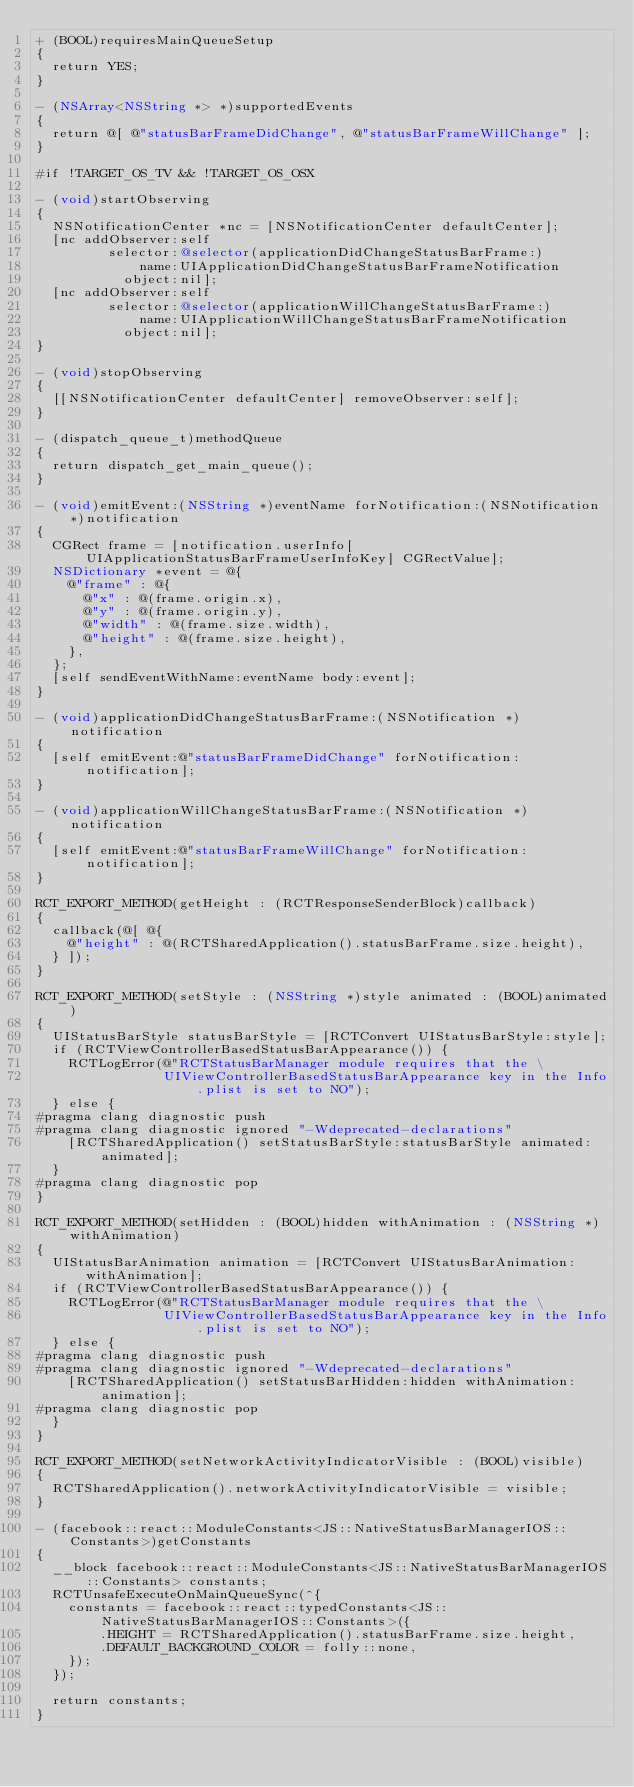<code> <loc_0><loc_0><loc_500><loc_500><_ObjectiveC_>+ (BOOL)requiresMainQueueSetup
{
  return YES;
}

- (NSArray<NSString *> *)supportedEvents
{
  return @[ @"statusBarFrameDidChange", @"statusBarFrameWillChange" ];
}

#if !TARGET_OS_TV && !TARGET_OS_OSX

- (void)startObserving
{
  NSNotificationCenter *nc = [NSNotificationCenter defaultCenter];
  [nc addObserver:self
         selector:@selector(applicationDidChangeStatusBarFrame:)
             name:UIApplicationDidChangeStatusBarFrameNotification
           object:nil];
  [nc addObserver:self
         selector:@selector(applicationWillChangeStatusBarFrame:)
             name:UIApplicationWillChangeStatusBarFrameNotification
           object:nil];
}

- (void)stopObserving
{
  [[NSNotificationCenter defaultCenter] removeObserver:self];
}

- (dispatch_queue_t)methodQueue
{
  return dispatch_get_main_queue();
}

- (void)emitEvent:(NSString *)eventName forNotification:(NSNotification *)notification
{
  CGRect frame = [notification.userInfo[UIApplicationStatusBarFrameUserInfoKey] CGRectValue];
  NSDictionary *event = @{
    @"frame" : @{
      @"x" : @(frame.origin.x),
      @"y" : @(frame.origin.y),
      @"width" : @(frame.size.width),
      @"height" : @(frame.size.height),
    },
  };
  [self sendEventWithName:eventName body:event];
}

- (void)applicationDidChangeStatusBarFrame:(NSNotification *)notification
{
  [self emitEvent:@"statusBarFrameDidChange" forNotification:notification];
}

- (void)applicationWillChangeStatusBarFrame:(NSNotification *)notification
{
  [self emitEvent:@"statusBarFrameWillChange" forNotification:notification];
}

RCT_EXPORT_METHOD(getHeight : (RCTResponseSenderBlock)callback)
{
  callback(@[ @{
    @"height" : @(RCTSharedApplication().statusBarFrame.size.height),
  } ]);
}

RCT_EXPORT_METHOD(setStyle : (NSString *)style animated : (BOOL)animated)
{
  UIStatusBarStyle statusBarStyle = [RCTConvert UIStatusBarStyle:style];
  if (RCTViewControllerBasedStatusBarAppearance()) {
    RCTLogError(@"RCTStatusBarManager module requires that the \
                UIViewControllerBasedStatusBarAppearance key in the Info.plist is set to NO");
  } else {
#pragma clang diagnostic push
#pragma clang diagnostic ignored "-Wdeprecated-declarations"
    [RCTSharedApplication() setStatusBarStyle:statusBarStyle animated:animated];
  }
#pragma clang diagnostic pop
}

RCT_EXPORT_METHOD(setHidden : (BOOL)hidden withAnimation : (NSString *)withAnimation)
{
  UIStatusBarAnimation animation = [RCTConvert UIStatusBarAnimation:withAnimation];
  if (RCTViewControllerBasedStatusBarAppearance()) {
    RCTLogError(@"RCTStatusBarManager module requires that the \
                UIViewControllerBasedStatusBarAppearance key in the Info.plist is set to NO");
  } else {
#pragma clang diagnostic push
#pragma clang diagnostic ignored "-Wdeprecated-declarations"
    [RCTSharedApplication() setStatusBarHidden:hidden withAnimation:animation];
#pragma clang diagnostic pop
  }
}

RCT_EXPORT_METHOD(setNetworkActivityIndicatorVisible : (BOOL)visible)
{
  RCTSharedApplication().networkActivityIndicatorVisible = visible;
}

- (facebook::react::ModuleConstants<JS::NativeStatusBarManagerIOS::Constants>)getConstants
{
  __block facebook::react::ModuleConstants<JS::NativeStatusBarManagerIOS::Constants> constants;
  RCTUnsafeExecuteOnMainQueueSync(^{
    constants = facebook::react::typedConstants<JS::NativeStatusBarManagerIOS::Constants>({
        .HEIGHT = RCTSharedApplication().statusBarFrame.size.height,
        .DEFAULT_BACKGROUND_COLOR = folly::none,
    });
  });

  return constants;
}
</code> 